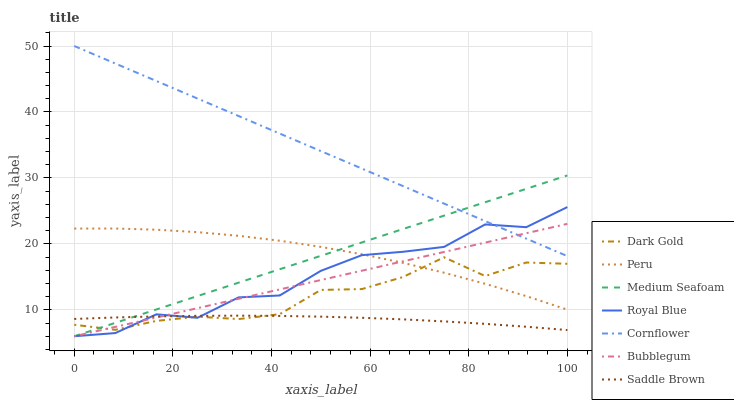Does Saddle Brown have the minimum area under the curve?
Answer yes or no. Yes. Does Cornflower have the maximum area under the curve?
Answer yes or no. Yes. Does Dark Gold have the minimum area under the curve?
Answer yes or no. No. Does Dark Gold have the maximum area under the curve?
Answer yes or no. No. Is Bubblegum the smoothest?
Answer yes or no. Yes. Is Royal Blue the roughest?
Answer yes or no. Yes. Is Dark Gold the smoothest?
Answer yes or no. No. Is Dark Gold the roughest?
Answer yes or no. No. Does Bubblegum have the lowest value?
Answer yes or no. Yes. Does Dark Gold have the lowest value?
Answer yes or no. No. Does Cornflower have the highest value?
Answer yes or no. Yes. Does Dark Gold have the highest value?
Answer yes or no. No. Is Saddle Brown less than Cornflower?
Answer yes or no. Yes. Is Cornflower greater than Peru?
Answer yes or no. Yes. Does Medium Seafoam intersect Dark Gold?
Answer yes or no. Yes. Is Medium Seafoam less than Dark Gold?
Answer yes or no. No. Is Medium Seafoam greater than Dark Gold?
Answer yes or no. No. Does Saddle Brown intersect Cornflower?
Answer yes or no. No. 